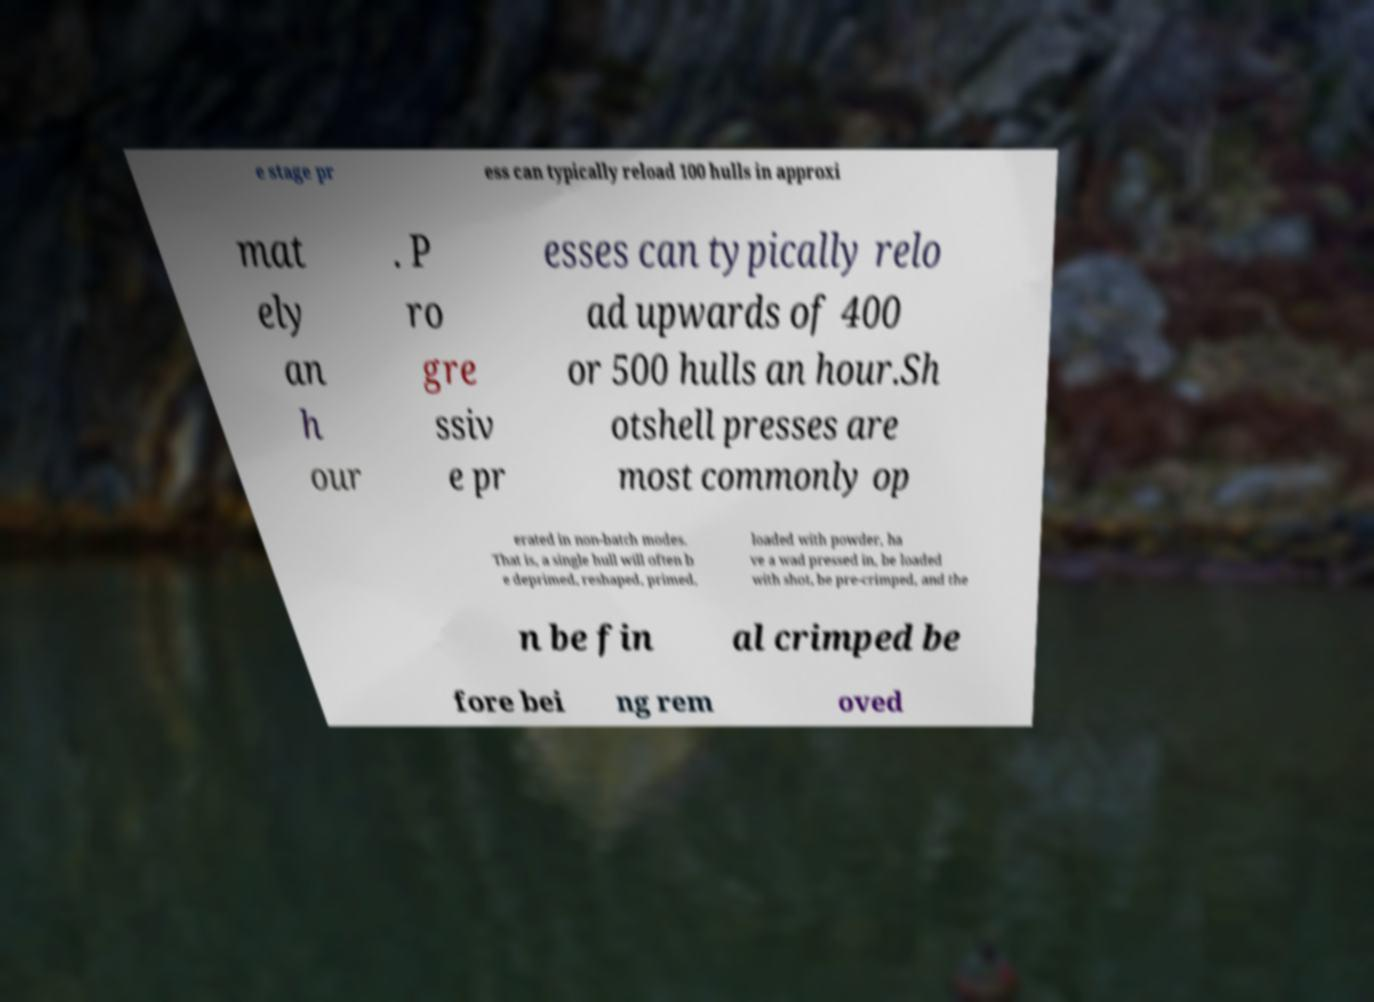For documentation purposes, I need the text within this image transcribed. Could you provide that? e stage pr ess can typically reload 100 hulls in approxi mat ely an h our . P ro gre ssiv e pr esses can typically relo ad upwards of 400 or 500 hulls an hour.Sh otshell presses are most commonly op erated in non-batch modes. That is, a single hull will often b e deprimed, reshaped, primed, loaded with powder, ha ve a wad pressed in, be loaded with shot, be pre-crimped, and the n be fin al crimped be fore bei ng rem oved 